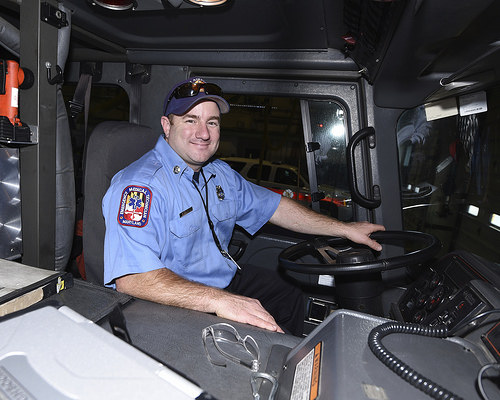<image>
Is the man on the steering wheel? Yes. Looking at the image, I can see the man is positioned on top of the steering wheel, with the steering wheel providing support. Where is the human in relation to the car? Is it to the right of the car? Yes. From this viewpoint, the human is positioned to the right side relative to the car. 